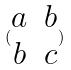<formula> <loc_0><loc_0><loc_500><loc_500>( \begin{matrix} a & b \\ b & c \end{matrix} )</formula> 